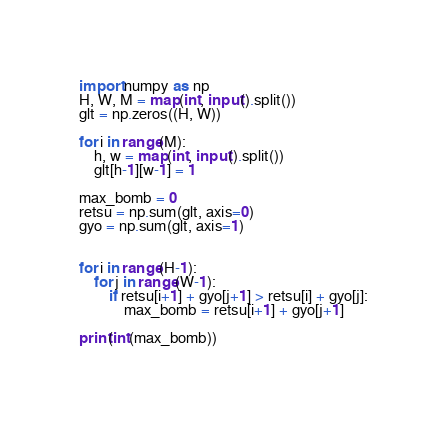<code> <loc_0><loc_0><loc_500><loc_500><_Python_>import numpy as np
H, W, M = map(int, input().split())
glt = np.zeros((H, W))

for i in range(M):
    h, w = map(int, input().split())
    glt[h-1][w-1] = 1
    
max_bomb = 0
retsu = np.sum(glt, axis=0)
gyo = np.sum(glt, axis=1)


for i in range(H-1):
    for j in range(W-1):
        if retsu[i+1] + gyo[j+1] > retsu[i] + gyo[j]:
            max_bomb = retsu[i+1] + gyo[j+1]
            
print(int(max_bomb))</code> 